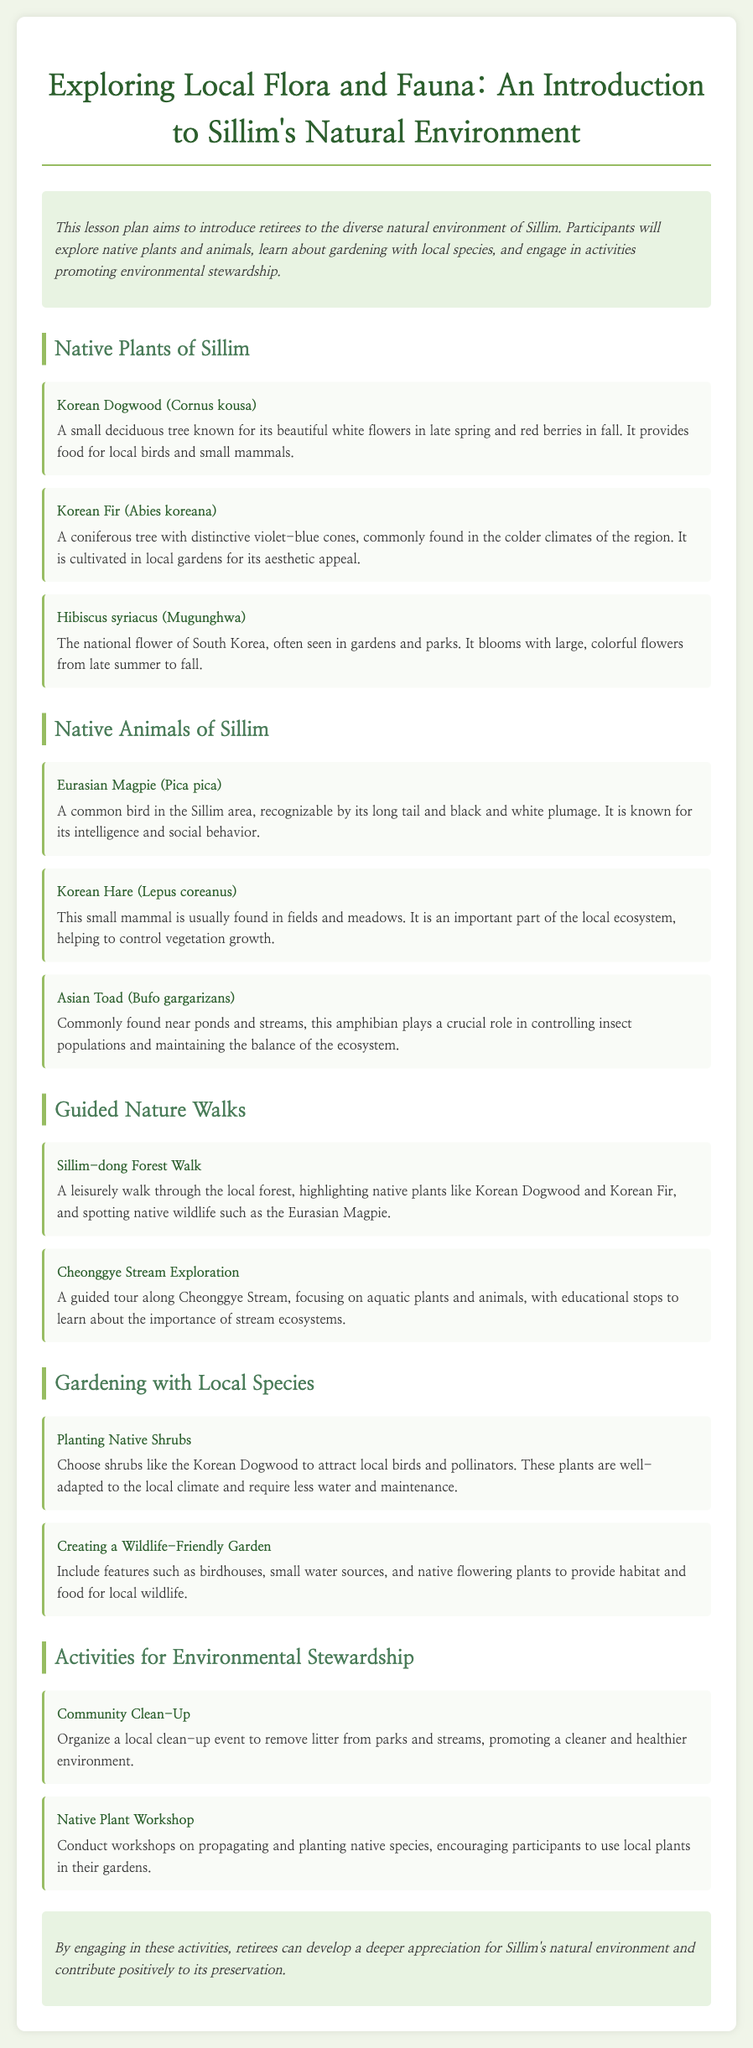What is the main goal of the lesson plan? The lesson plan aims to introduce retirees to the diverse natural environment of Sillim.
Answer: Introduce retirees to the diverse natural environment of Sillim What is the national flower of South Korea mentioned in the document? The document lists Hibiscus syriacus, also known as Mugunghwa, as the national flower of South Korea.
Answer: Hibiscus syriacus Which animal is noted for its intelligence and is common in the Sillim area? The Eurasian Magpie is described as being known for its intelligence and social behavior.
Answer: Eurasian Magpie How many guided nature walks are mentioned in the document? There are two guided nature walks included in the lesson plan.
Answer: Two What type of gardening activity is suggested to attract local wildlife? The document suggests creating a wildlife-friendly garden as an activity for environmental stewardship.
Answer: Creating a wildlife-friendly garden What is the name of the workshop focused on native species? The Native Plant Workshop is mentioned as a way to encourage the use of local plants in gardens.
Answer: Native Plant Workshop What plant is highlighted for its violet-blue cones? The Korean Fir is noted for its distinctive violet-blue cones in the description of native plants.
Answer: Korean Fir What is one of the activities suggested to promote environmental stewardship? Organizing a community clean-up event is listed as an activity for environmental stewardship.
Answer: Community Clean-Up 